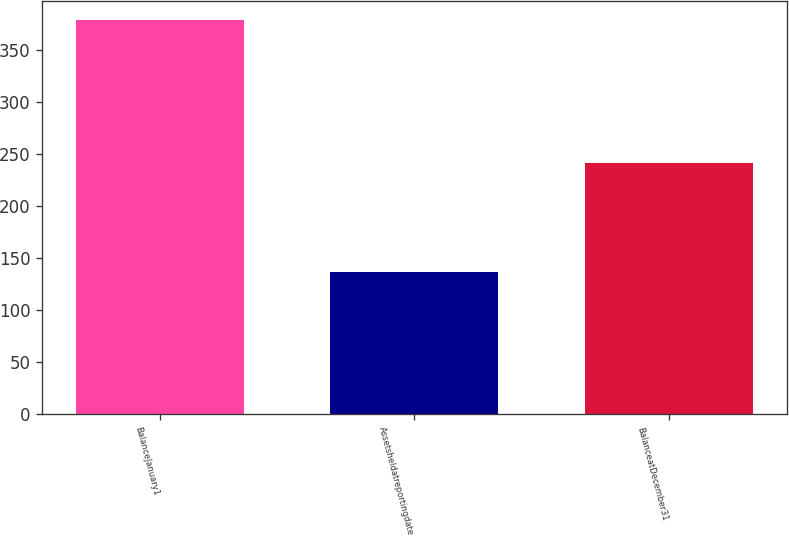Convert chart to OTSL. <chart><loc_0><loc_0><loc_500><loc_500><bar_chart><fcel>BalanceJanuary1<fcel>Assetsheldatreportingdate<fcel>BalanceatDecember31<nl><fcel>379<fcel>137<fcel>242<nl></chart> 